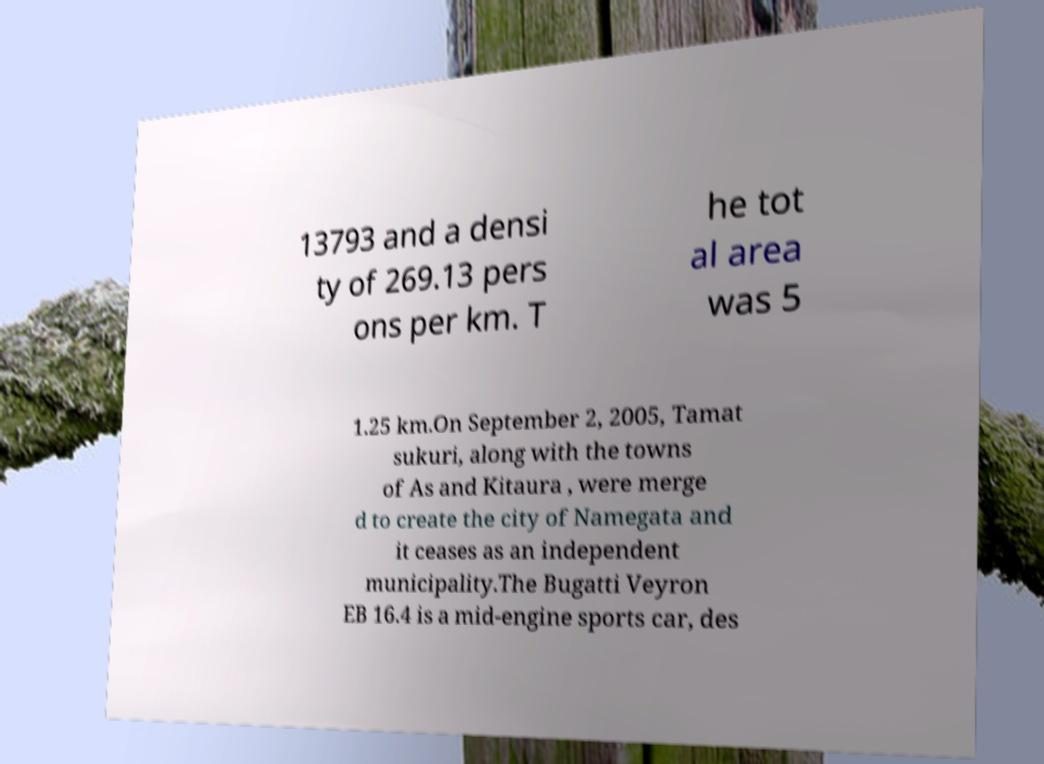Could you assist in decoding the text presented in this image and type it out clearly? 13793 and a densi ty of 269.13 pers ons per km. T he tot al area was 5 1.25 km.On September 2, 2005, Tamat sukuri, along with the towns of As and Kitaura , were merge d to create the city of Namegata and it ceases as an independent municipality.The Bugatti Veyron EB 16.4 is a mid-engine sports car, des 